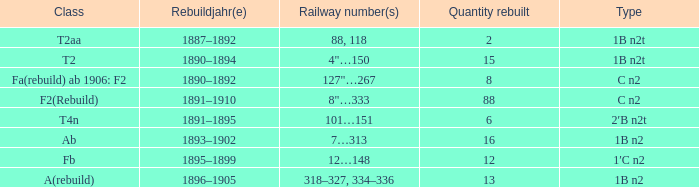What is the total of quantity rebuilt if the type is 1B N2T and the railway number is 88, 118? 1.0. 